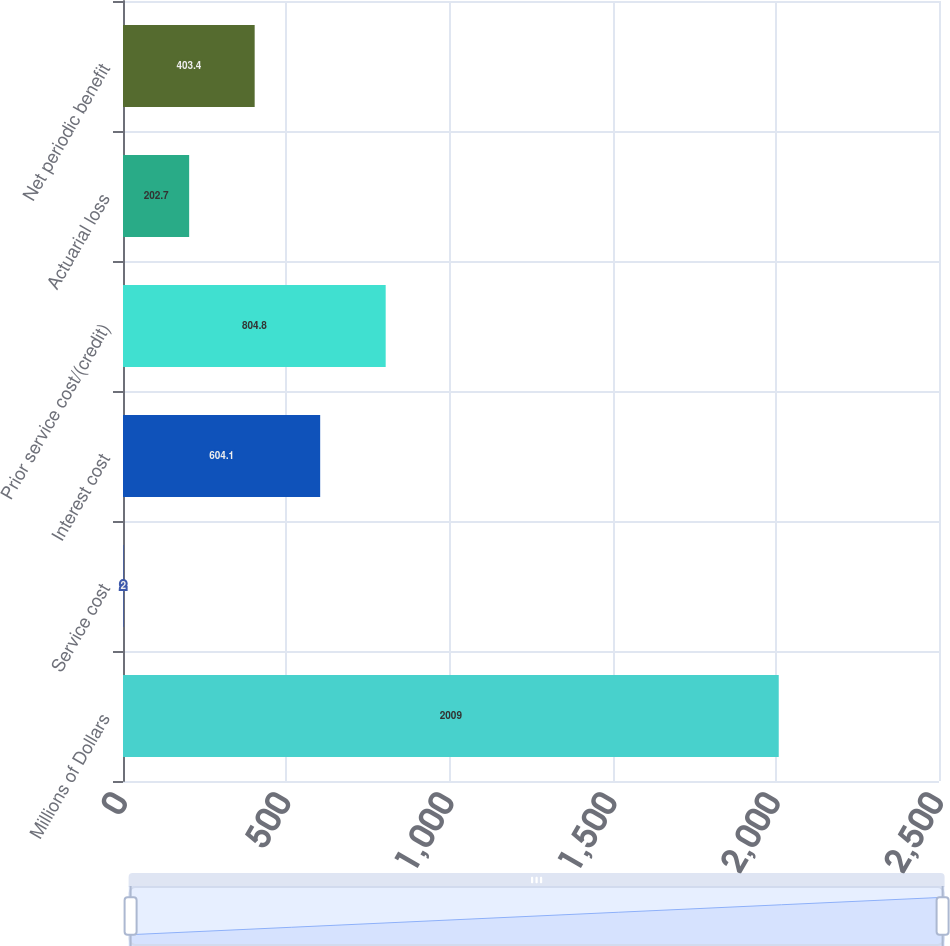Convert chart. <chart><loc_0><loc_0><loc_500><loc_500><bar_chart><fcel>Millions of Dollars<fcel>Service cost<fcel>Interest cost<fcel>Prior service cost/(credit)<fcel>Actuarial loss<fcel>Net periodic benefit<nl><fcel>2009<fcel>2<fcel>604.1<fcel>804.8<fcel>202.7<fcel>403.4<nl></chart> 